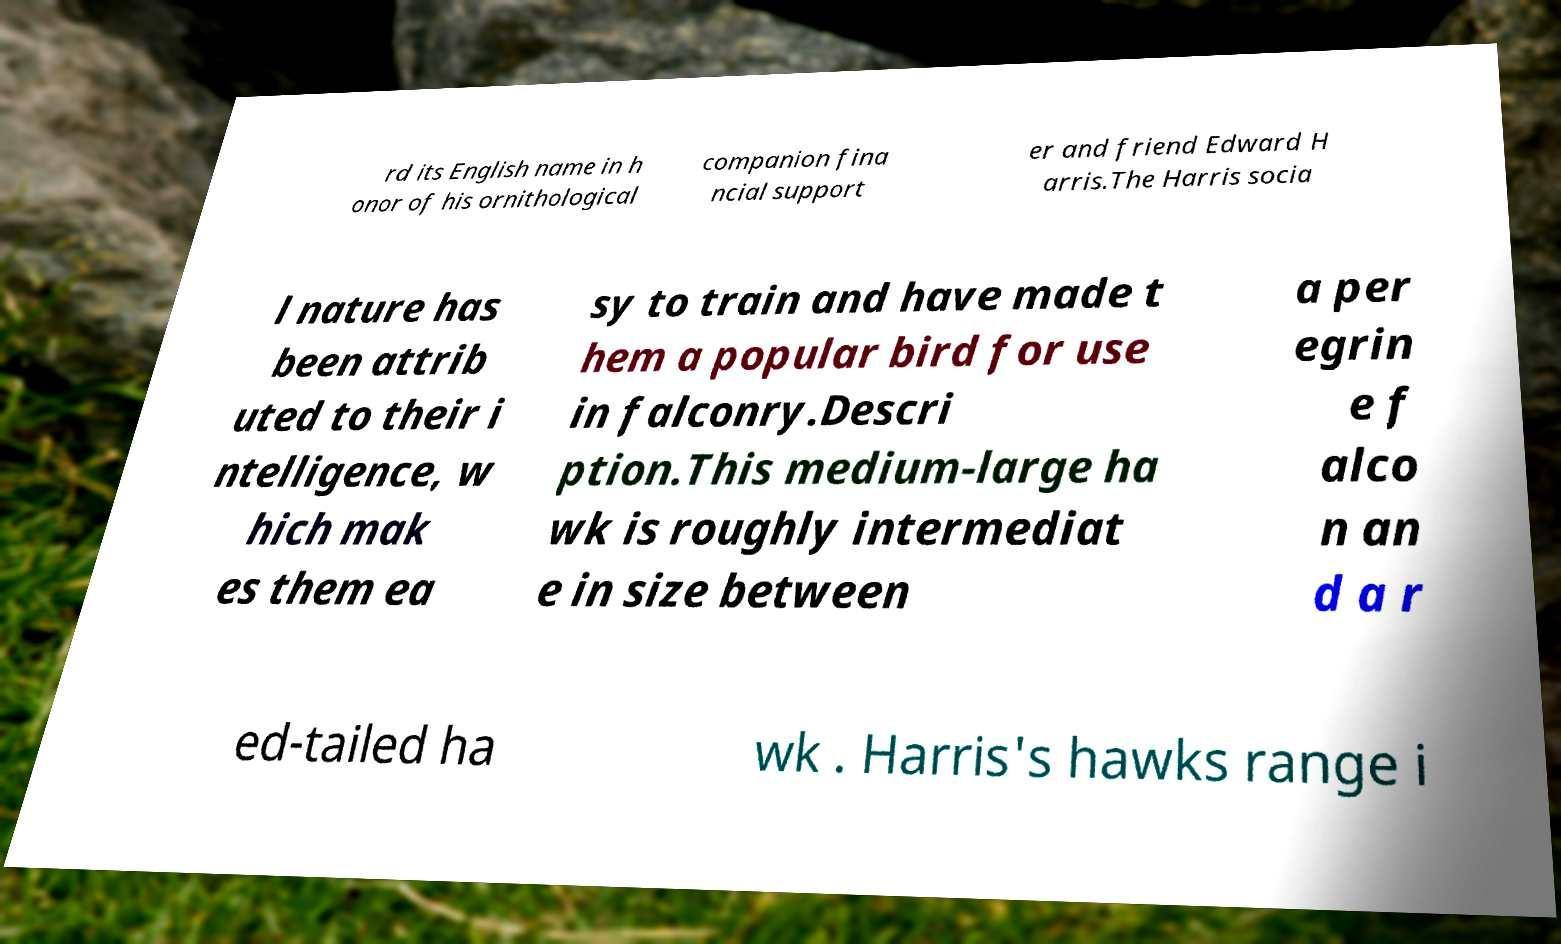Could you extract and type out the text from this image? rd its English name in h onor of his ornithological companion fina ncial support er and friend Edward H arris.The Harris socia l nature has been attrib uted to their i ntelligence, w hich mak es them ea sy to train and have made t hem a popular bird for use in falconry.Descri ption.This medium-large ha wk is roughly intermediat e in size between a per egrin e f alco n an d a r ed-tailed ha wk . Harris's hawks range i 